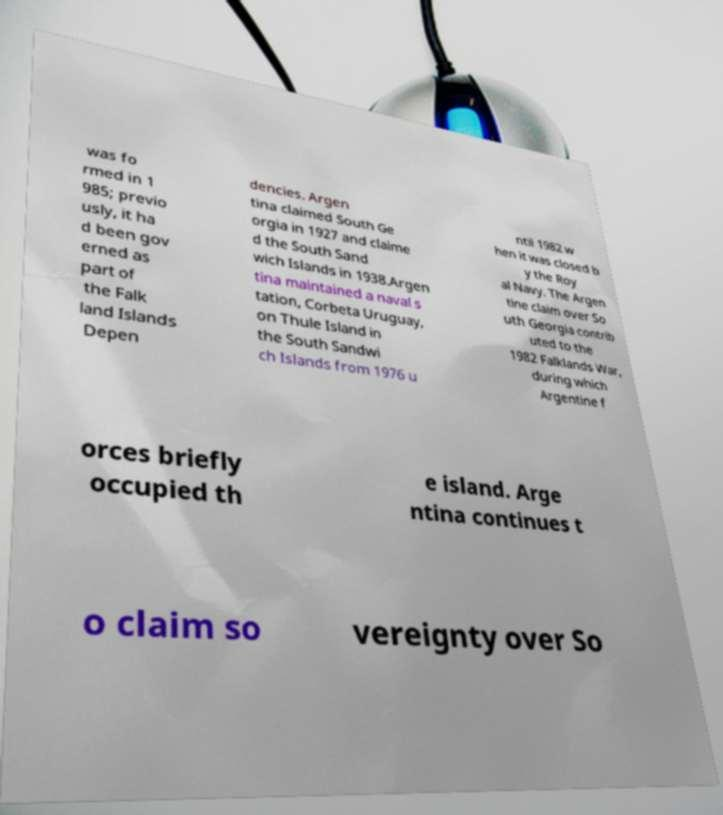There's text embedded in this image that I need extracted. Can you transcribe it verbatim? was fo rmed in 1 985; previo usly, it ha d been gov erned as part of the Falk land Islands Depen dencies. Argen tina claimed South Ge orgia in 1927 and claime d the South Sand wich Islands in 1938.Argen tina maintained a naval s tation, Corbeta Uruguay, on Thule Island in the South Sandwi ch Islands from 1976 u ntil 1982 w hen it was closed b y the Roy al Navy. The Argen tine claim over So uth Georgia contrib uted to the 1982 Falklands War, during which Argentine f orces briefly occupied th e island. Arge ntina continues t o claim so vereignty over So 